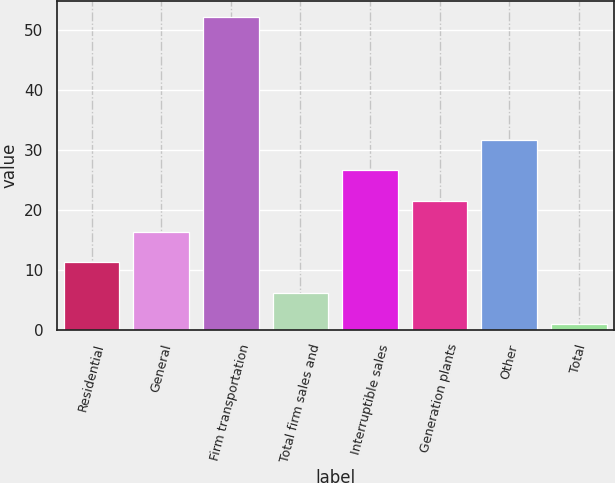Convert chart to OTSL. <chart><loc_0><loc_0><loc_500><loc_500><bar_chart><fcel>Residential<fcel>General<fcel>Firm transportation<fcel>Total firm sales and<fcel>Interruptible sales<fcel>Generation plants<fcel>Other<fcel>Total<nl><fcel>11.24<fcel>16.36<fcel>52.2<fcel>6.12<fcel>26.6<fcel>21.48<fcel>31.72<fcel>1<nl></chart> 